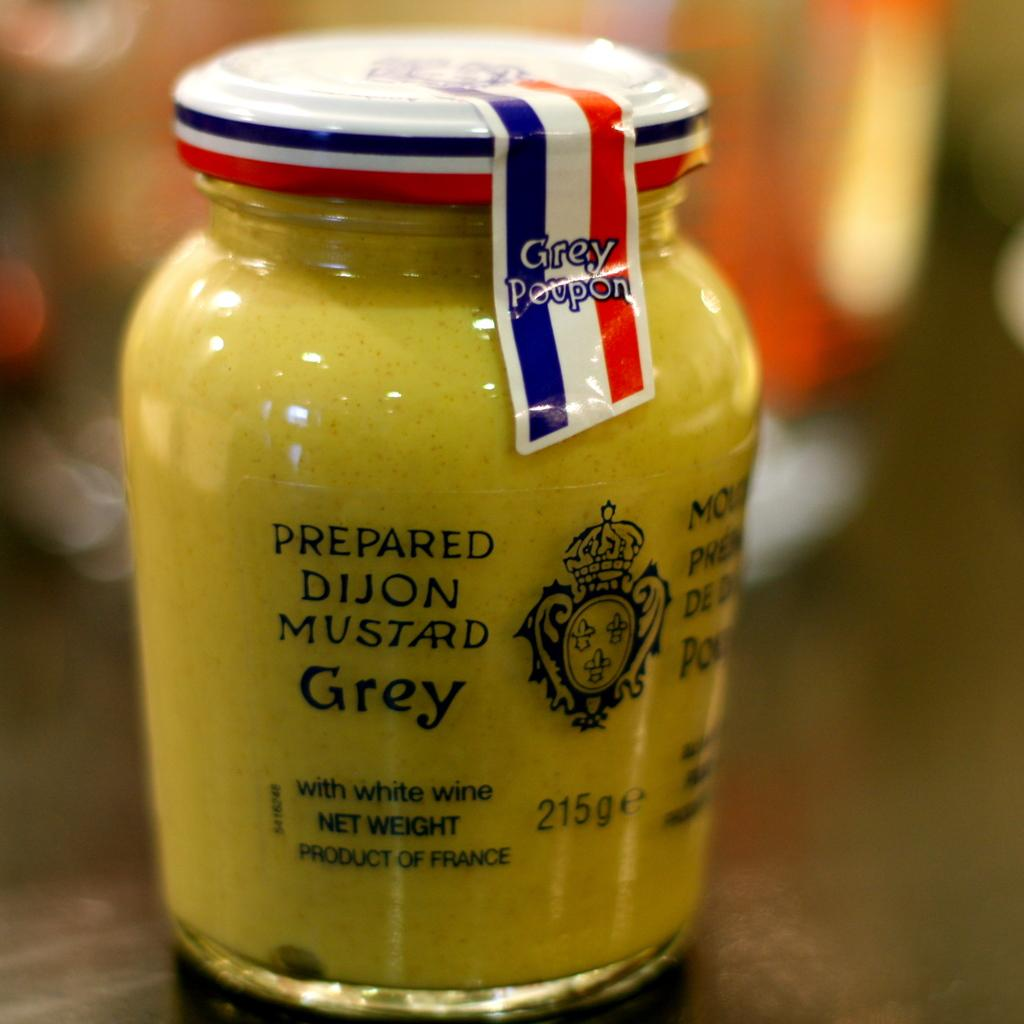Provide a one-sentence caption for the provided image. A jar of Dijon mustard on a table. 